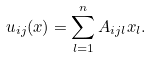Convert formula to latex. <formula><loc_0><loc_0><loc_500><loc_500>u _ { i j } ( x ) = \sum _ { l = 1 } ^ { n } A _ { i j l } x _ { l } .</formula> 